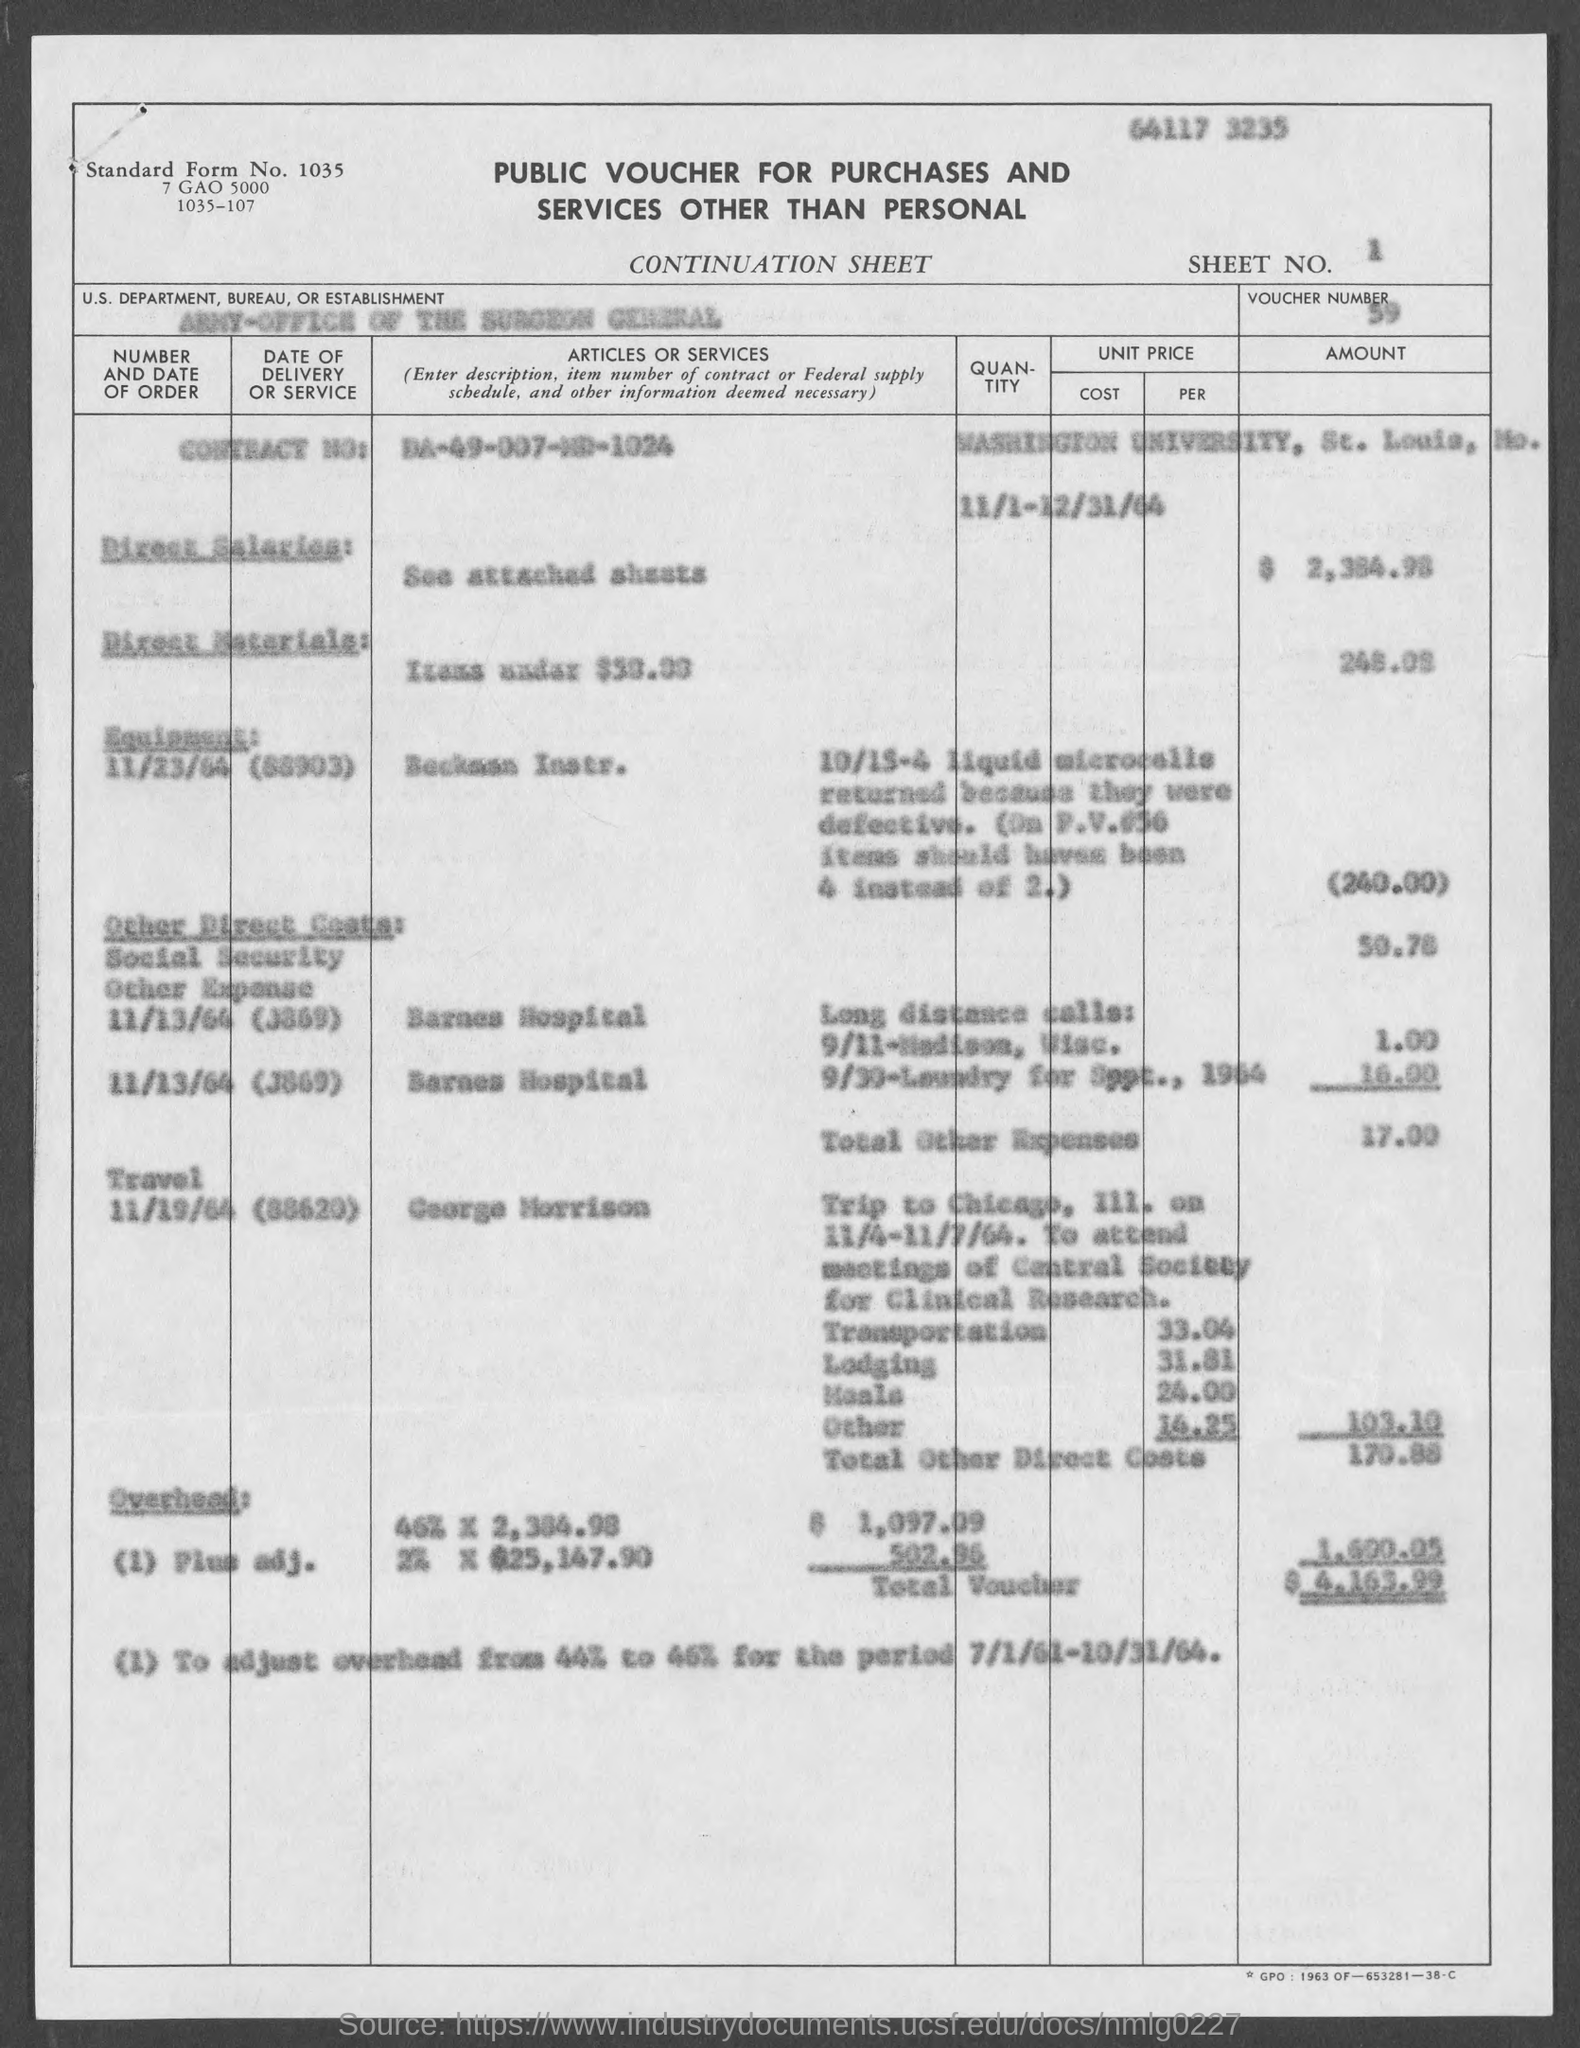Specify some key components in this picture. The voucher indicates that the U.S. Department, Bureau, or Establishment mentioned is the Army-Office of the Surgeon General. The voucher contains a Contract No. of DA-49-007-MD-1024. What is the standard form number given in the document? 1035... Please indicate the sheet number indicated in the voucher as follows: 1.. The voucher number provided in the document is 59. 